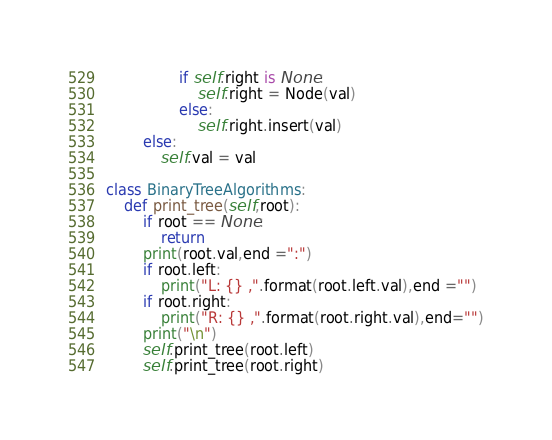Convert code to text. <code><loc_0><loc_0><loc_500><loc_500><_Python_>                if self.right is None:
                    self.right = Node(val)
                else:
                    self.right.insert(val)
        else:
            self.val = val

class BinaryTreeAlgorithms:
    def print_tree(self,root):
        if root == None:
            return
        print(root.val,end =":")
        if root.left:
            print("L: {} ,".format(root.left.val),end ="")
        if root.right:
            print("R: {} ,".format(root.right.val),end="")
        print("\n")
        self.print_tree(root.left)
        self.print_tree(root.right)
</code> 